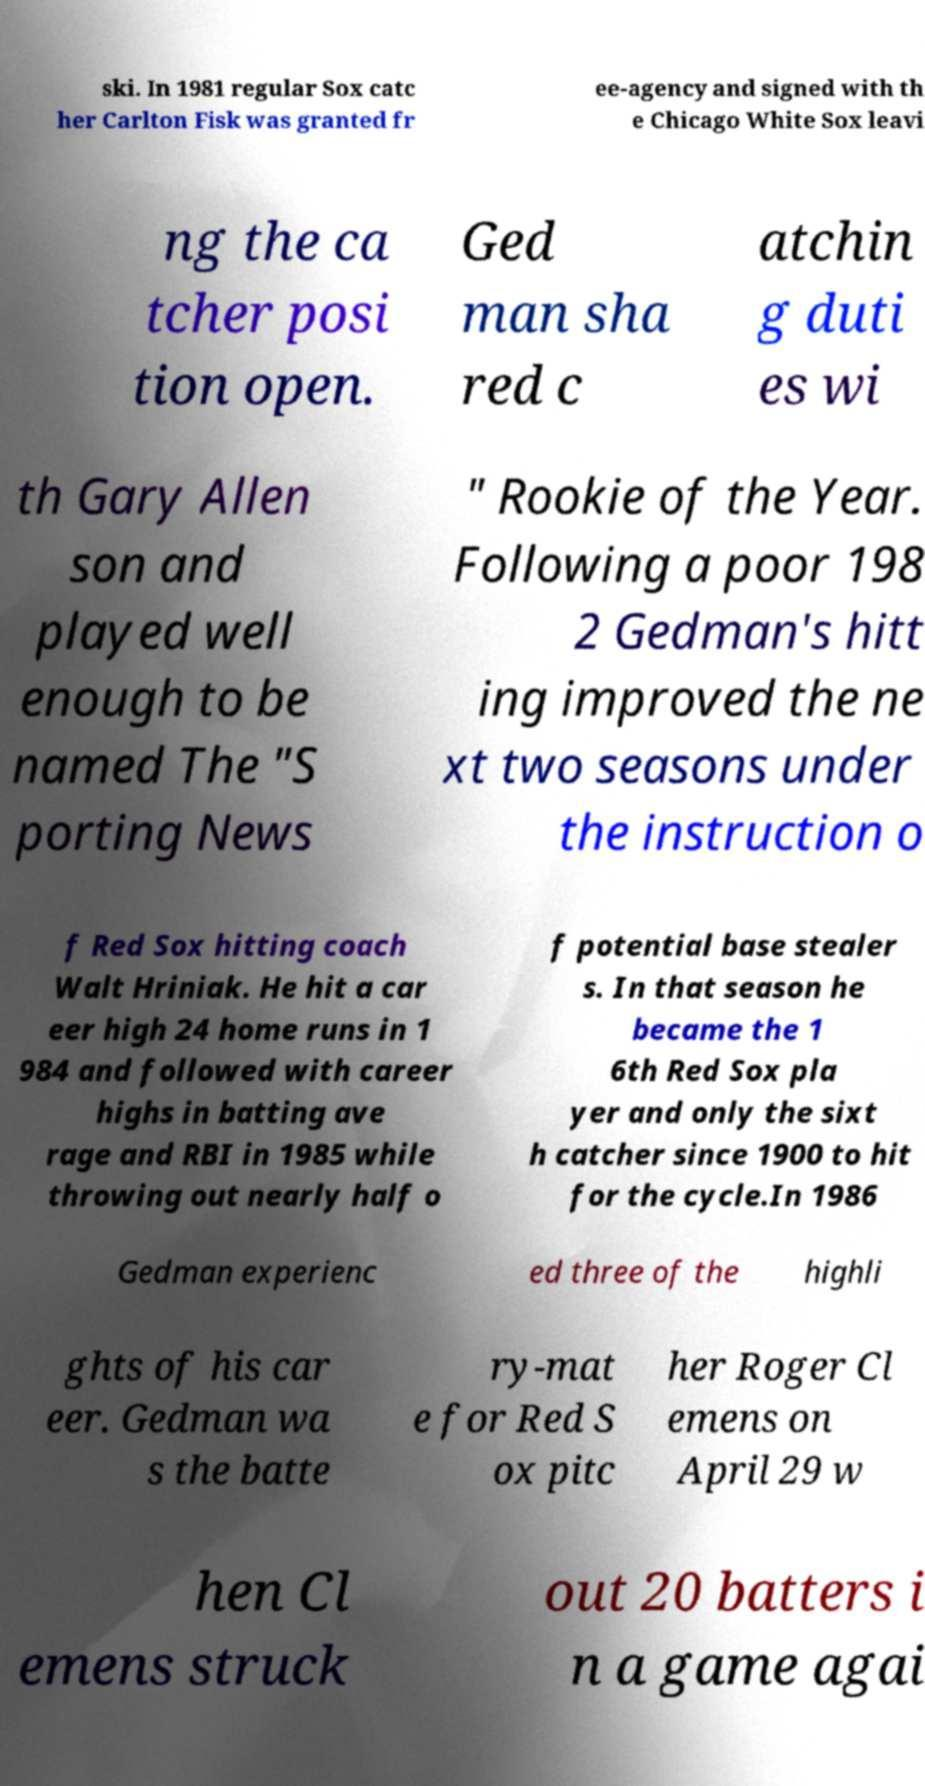I need the written content from this picture converted into text. Can you do that? ski. In 1981 regular Sox catc her Carlton Fisk was granted fr ee-agency and signed with th e Chicago White Sox leavi ng the ca tcher posi tion open. Ged man sha red c atchin g duti es wi th Gary Allen son and played well enough to be named The "S porting News " Rookie of the Year. Following a poor 198 2 Gedman's hitt ing improved the ne xt two seasons under the instruction o f Red Sox hitting coach Walt Hriniak. He hit a car eer high 24 home runs in 1 984 and followed with career highs in batting ave rage and RBI in 1985 while throwing out nearly half o f potential base stealer s. In that season he became the 1 6th Red Sox pla yer and only the sixt h catcher since 1900 to hit for the cycle.In 1986 Gedman experienc ed three of the highli ghts of his car eer. Gedman wa s the batte ry-mat e for Red S ox pitc her Roger Cl emens on April 29 w hen Cl emens struck out 20 batters i n a game agai 